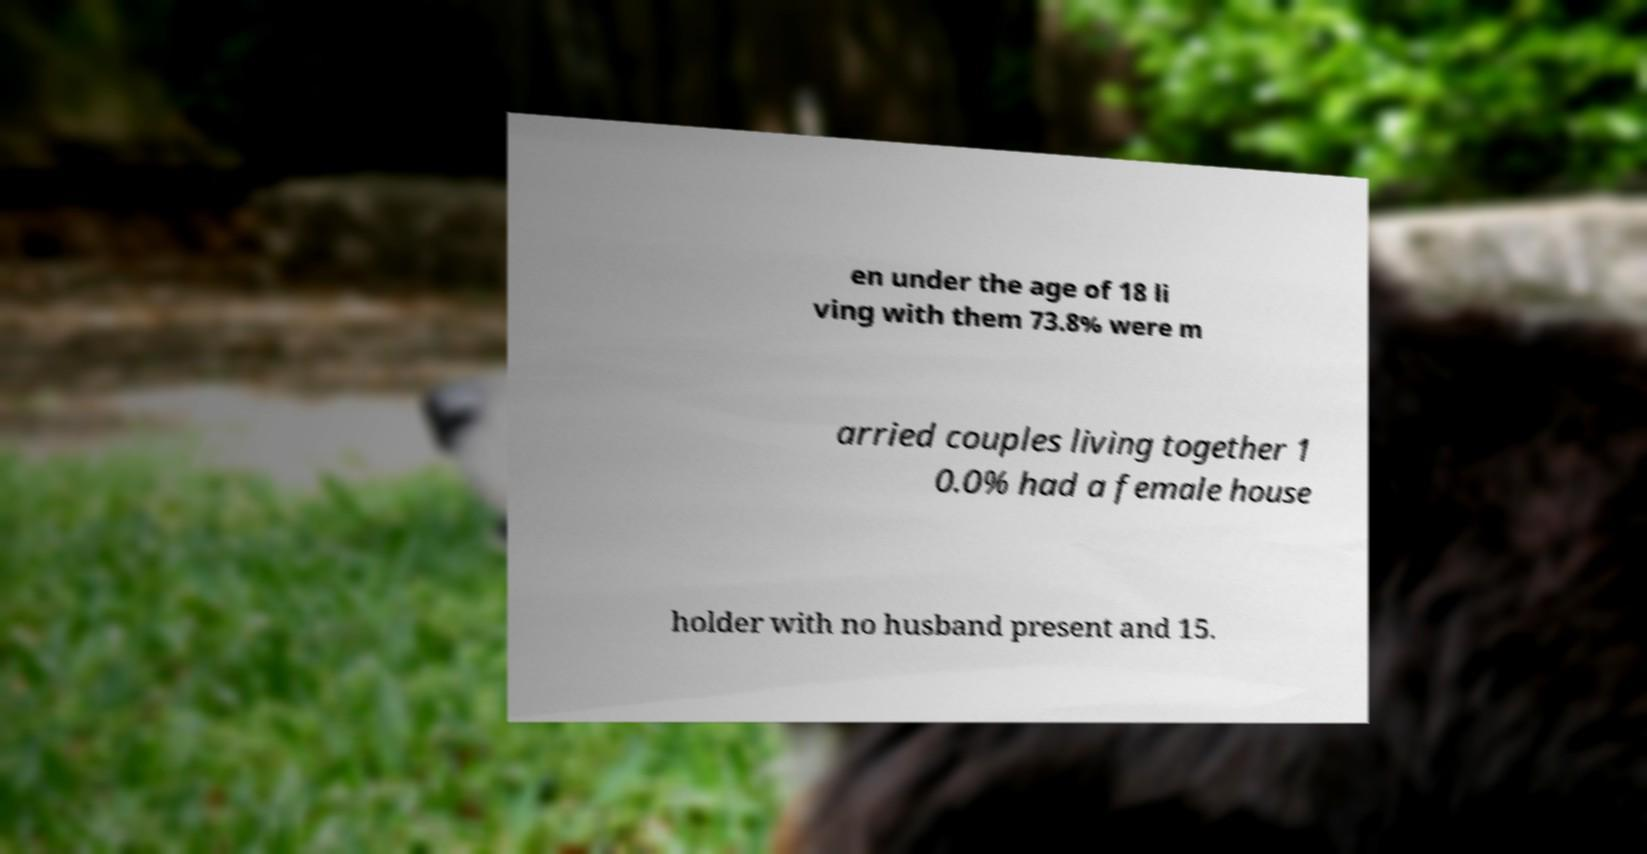Could you assist in decoding the text presented in this image and type it out clearly? en under the age of 18 li ving with them 73.8% were m arried couples living together 1 0.0% had a female house holder with no husband present and 15. 